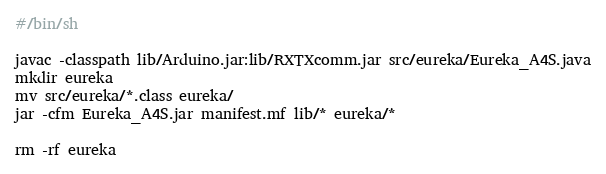<code> <loc_0><loc_0><loc_500><loc_500><_Bash_>#/bin/sh

javac -classpath lib/Arduino.jar:lib/RXTXcomm.jar src/eureka/Eureka_A4S.java
mkdir eureka
mv src/eureka/*.class eureka/
jar -cfm Eureka_A4S.jar manifest.mf lib/* eureka/*

rm -rf eureka
</code> 